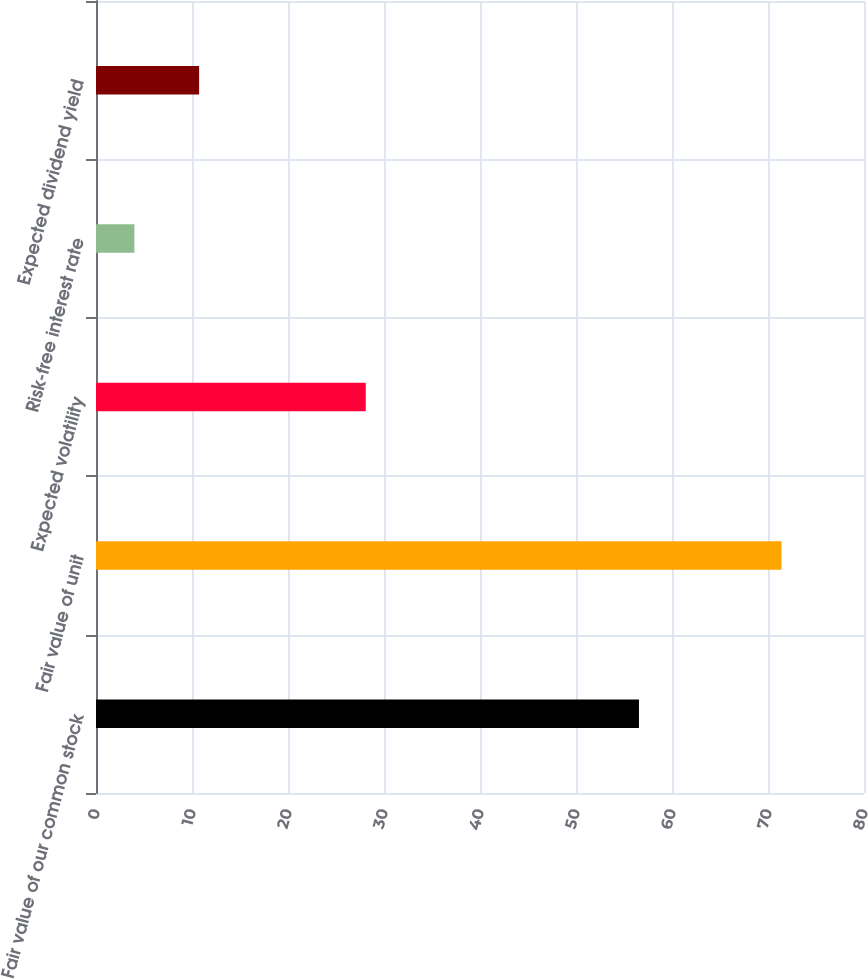Convert chart to OTSL. <chart><loc_0><loc_0><loc_500><loc_500><bar_chart><fcel>Fair value of our common stock<fcel>Fair value of unit<fcel>Expected volatility<fcel>Risk-free interest rate<fcel>Expected dividend yield<nl><fcel>56.56<fcel>71.41<fcel>28.1<fcel>4<fcel>10.74<nl></chart> 